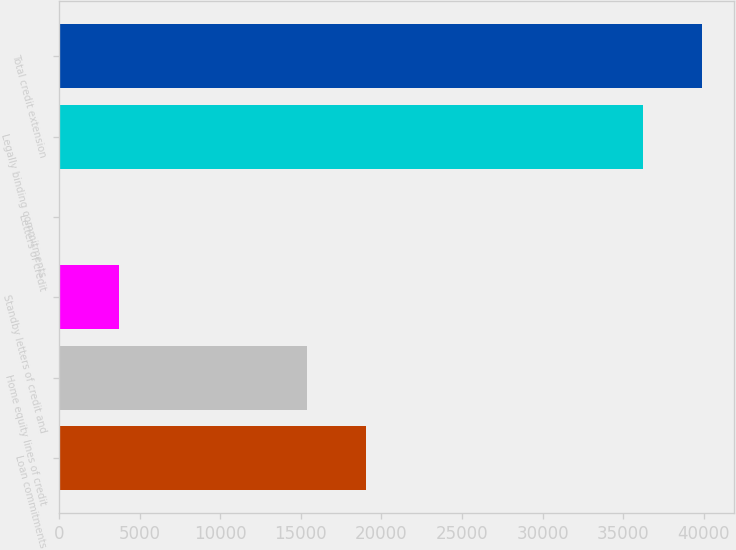<chart> <loc_0><loc_0><loc_500><loc_500><bar_chart><fcel>Loan commitments<fcel>Home equity lines of credit<fcel>Standby letters of credit and<fcel>Letters of credit<fcel>Legally binding commitments<fcel>Total credit extension<nl><fcel>19033.6<fcel>15417<fcel>3704.6<fcel>88<fcel>36254<fcel>39870.6<nl></chart> 